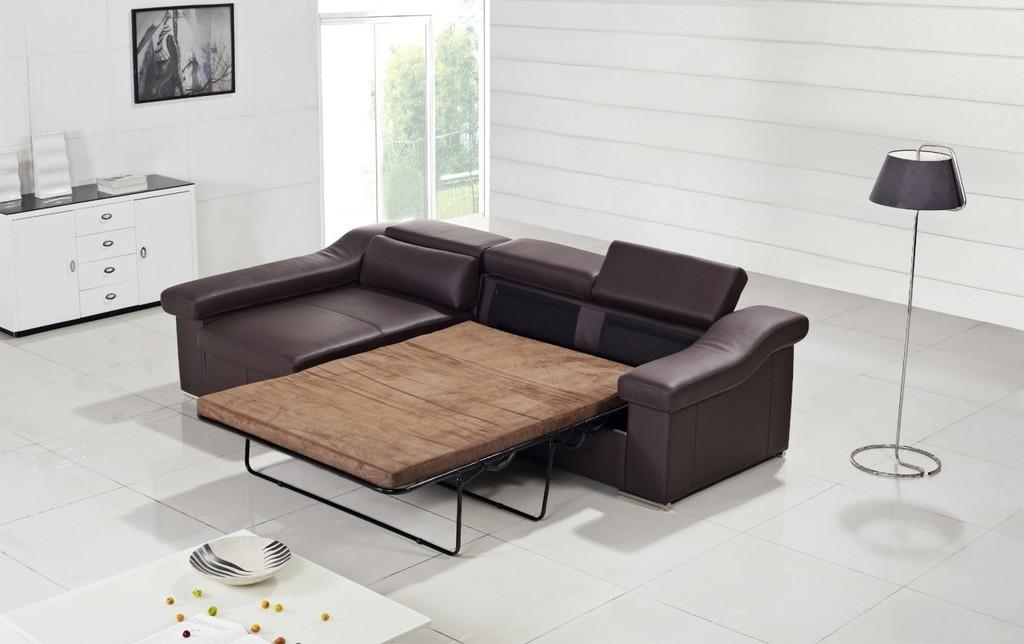What type of furniture is present in the image? There is a sofa in the image. What is located beside the sofa? There is a table with a lamp beside the sofa. Are there any other tables in the image? Yes, there is another table in the image. What is on the second table? The second table has a bowl on it. Is there any decoration on the wall in the image? Yes, there is a photo frame on the wall. What type of clouds can be seen through the window in the image? There is no window or clouds visible in the image. What book is the person reading in the image? There is no person or book present in the image. 